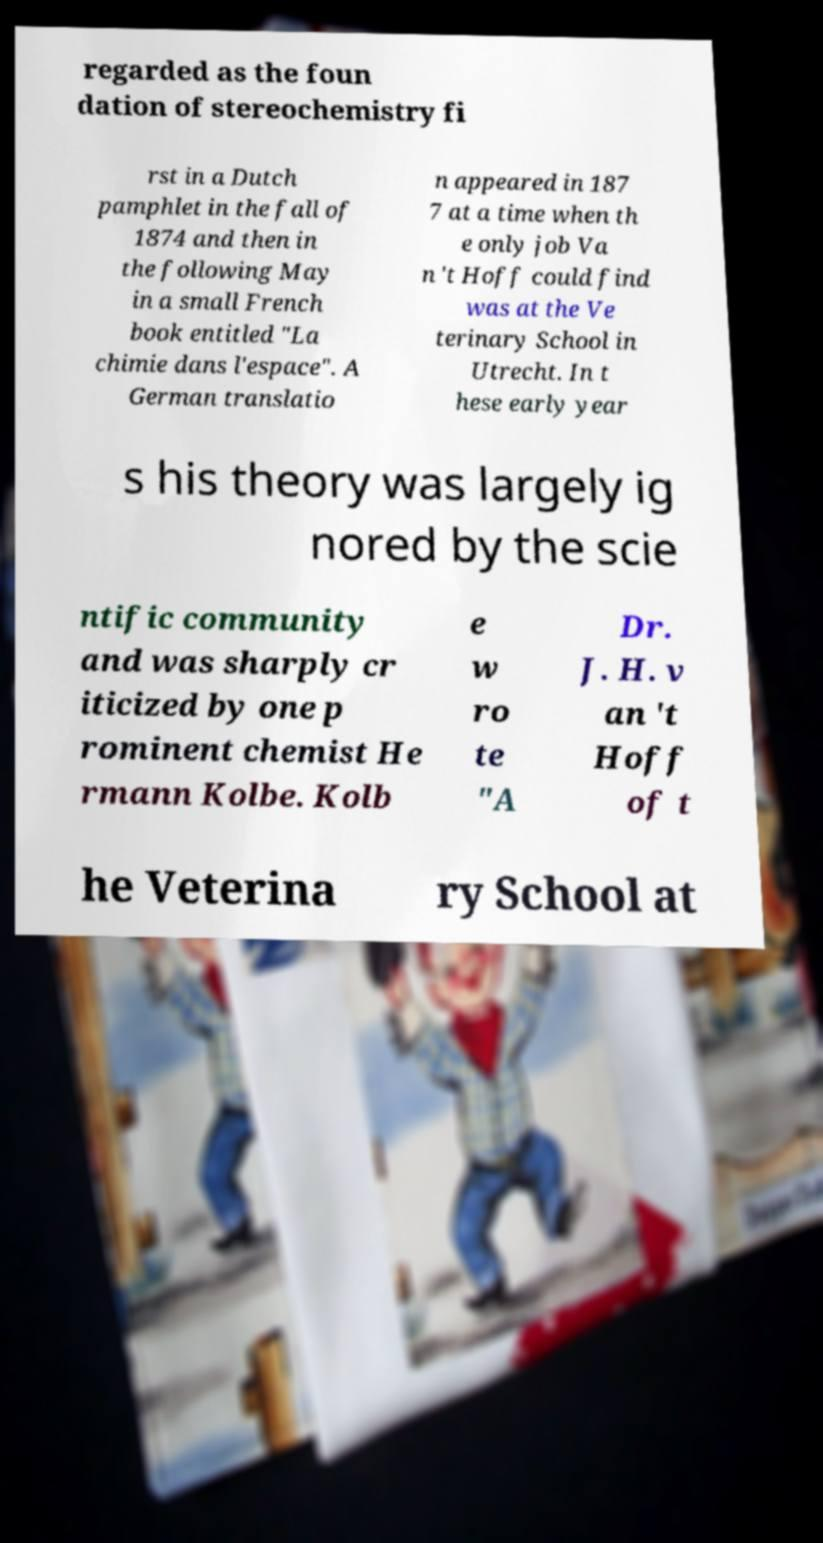Can you accurately transcribe the text from the provided image for me? regarded as the foun dation of stereochemistry fi rst in a Dutch pamphlet in the fall of 1874 and then in the following May in a small French book entitled "La chimie dans l'espace". A German translatio n appeared in 187 7 at a time when th e only job Va n 't Hoff could find was at the Ve terinary School in Utrecht. In t hese early year s his theory was largely ig nored by the scie ntific community and was sharply cr iticized by one p rominent chemist He rmann Kolbe. Kolb e w ro te "A Dr. J. H. v an 't Hoff of t he Veterina ry School at 